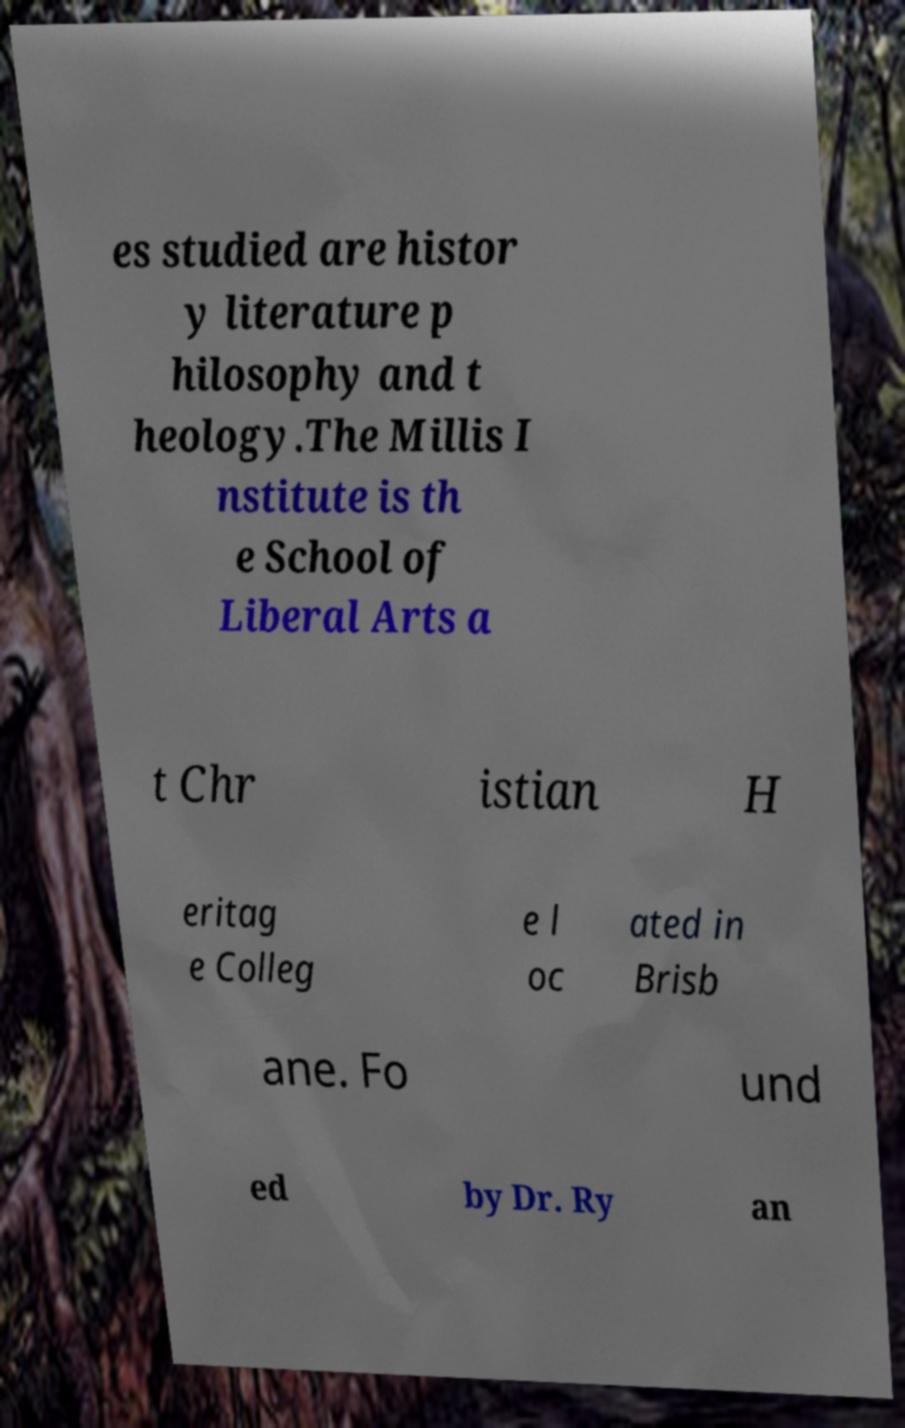I need the written content from this picture converted into text. Can you do that? es studied are histor y literature p hilosophy and t heology.The Millis I nstitute is th e School of Liberal Arts a t Chr istian H eritag e Colleg e l oc ated in Brisb ane. Fo und ed by Dr. Ry an 